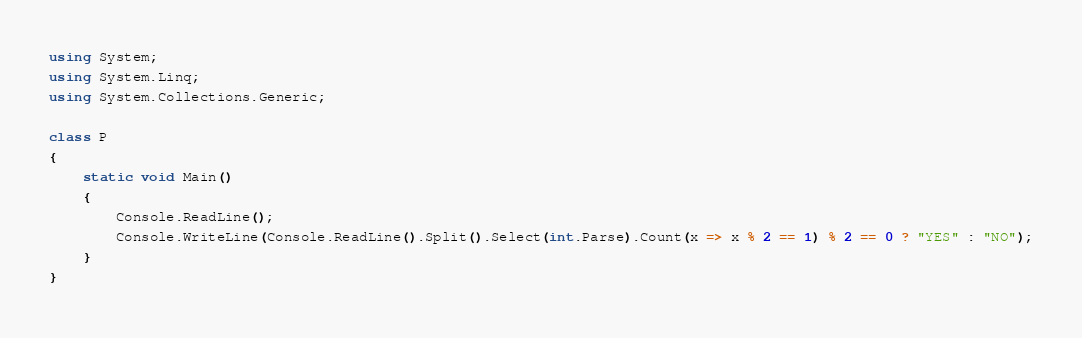Convert code to text. <code><loc_0><loc_0><loc_500><loc_500><_C#_>using System;
using System.Linq;
using System.Collections.Generic;

class P
{
    static void Main()
    {
        Console.ReadLine();
        Console.WriteLine(Console.ReadLine().Split().Select(int.Parse).Count(x => x % 2 == 1) % 2 == 0 ? "YES" : "NO");
    }
}</code> 